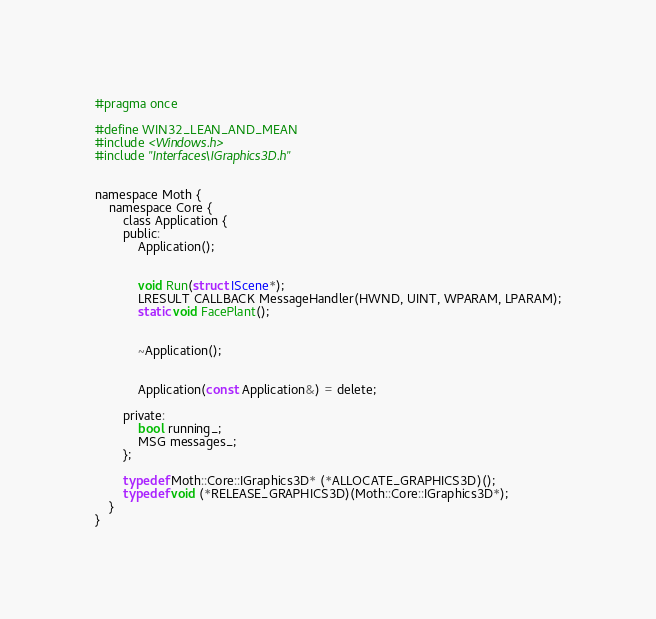Convert code to text. <code><loc_0><loc_0><loc_500><loc_500><_C_>#pragma once

#define WIN32_LEAN_AND_MEAN
#include <Windows.h>
#include "Interfaces\IGraphics3D.h"


namespace Moth {
	namespace Core {
		class Application {
		public:
			Application();


			void Run(struct IScene*);
			LRESULT CALLBACK MessageHandler(HWND, UINT, WPARAM, LPARAM);
			static void FacePlant();


			~Application();


			Application(const Application&) = delete;

		private:
			bool running_;
			MSG messages_;
		};

		typedef Moth::Core::IGraphics3D* (*ALLOCATE_GRAPHICS3D)();
		typedef void (*RELEASE_GRAPHICS3D)(Moth::Core::IGraphics3D*);
	}
}</code> 